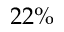<formula> <loc_0><loc_0><loc_500><loc_500>2 2 \%</formula> 